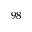<formula> <loc_0><loc_0><loc_500><loc_500>^ { 9 8 }</formula> 